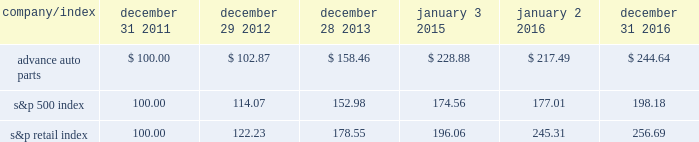Stock price performance the following graph shows a comparison of the cumulative total return on our common stock , the standard & poor 2019s 500 index and the standard & poor 2019s retail index .
The graph assumes that the value of an investment in our common stock and in each such index was $ 100 on december 31 , 2011 , and that any dividends have been reinvested .
The comparison in the graph below is based solely on historical data and is not intended to forecast the possible future performance of our common stock .
Comparison of cumulative total return among advance auto parts , inc. , s&p 500 index and s&p retail index company/index december 31 , december 29 , december 28 , january 3 , january 2 , december 31 .

What is the rate of return on an investment in s&p500 index from 2015 to 2016? 
Computations: ((177.01 - 174.56) / 174.56)
Answer: 0.01404. 